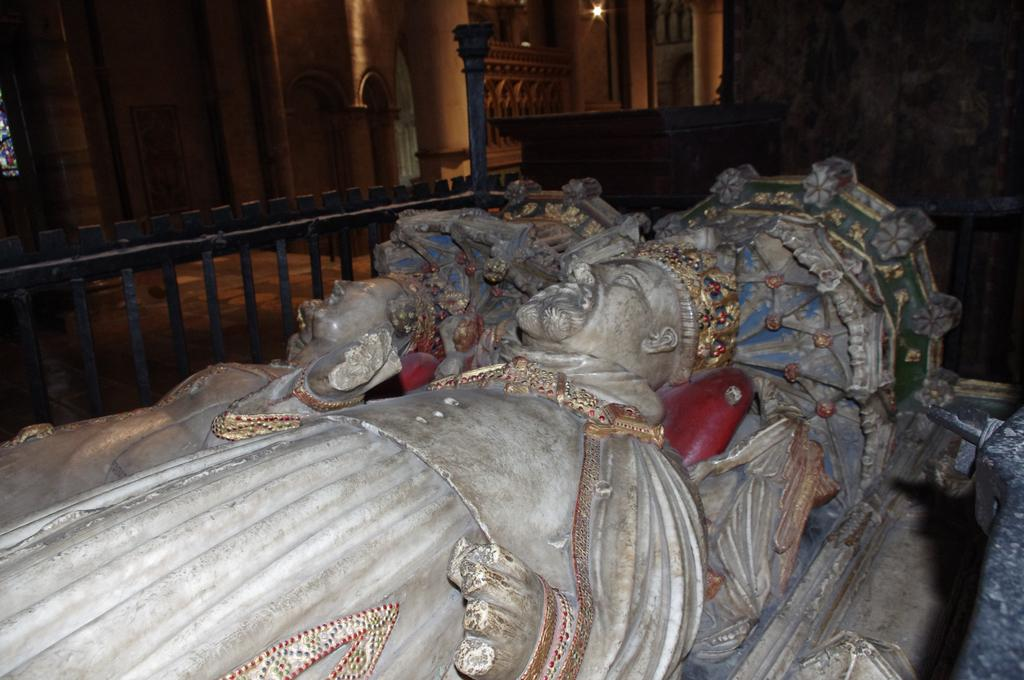What architectural features can be seen in the background of the image? There are pillars in the background of the image. What type of lighting is visible in the background of the image? There is light visible in the background of the image. What other structural elements can be seen in the background of the image? There is a wall and a floor in the background of the image. What is the purpose of the railing in the image? The railing in the image is likely for safety or support. What type of decorative objects are present in the image? There are statues in the image. How many lizards are crawling on the statues in the image? There are no lizards present in the image; it only features statues. What type of sweater is the person wearing in the image? There is no person wearing a sweater in the image; it only features statues and architectural elements. 